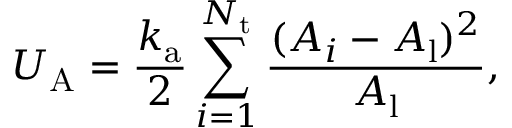Convert formula to latex. <formula><loc_0><loc_0><loc_500><loc_500>U _ { A } = \frac { k _ { a } } { 2 } \sum _ { i = 1 } ^ { N _ { t } } \frac { ( A _ { i } - A _ { l } ) ^ { 2 } } { A _ { l } } ,</formula> 